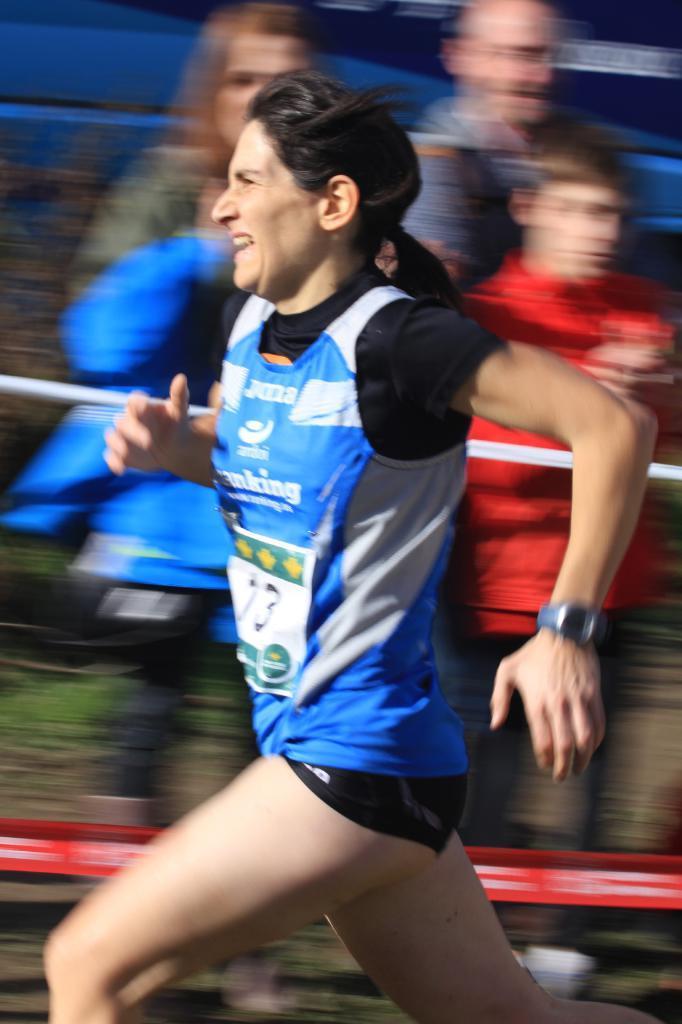Could you give a brief overview of what you see in this image? This picture describes about few people, in the middle of the image we can see a woman and she is running, we can see blurry background. 